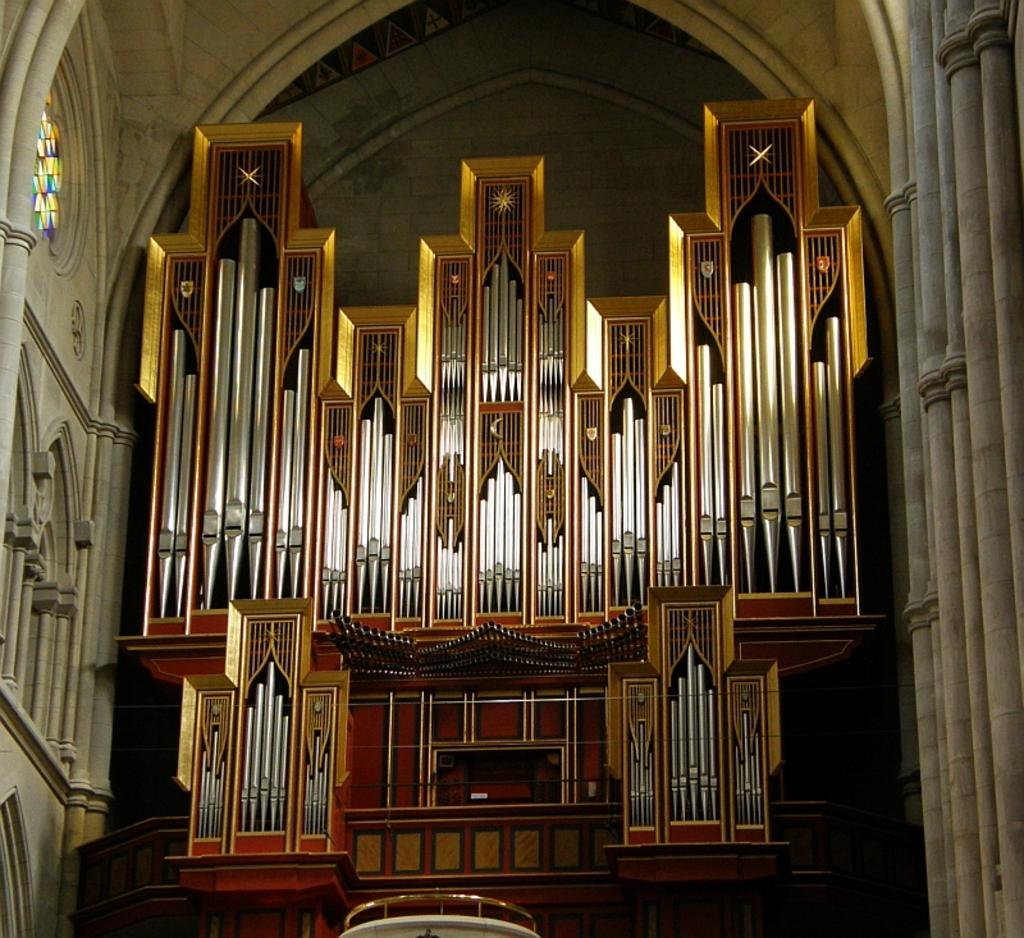What type of view is shown in the image? The image is an inner view. What can be observed in the image in terms of man-made structures? The image contains architecture. What type of farm animals can be seen in the image? There are no farm animals present in the image, as it is an inner view containing architecture. 